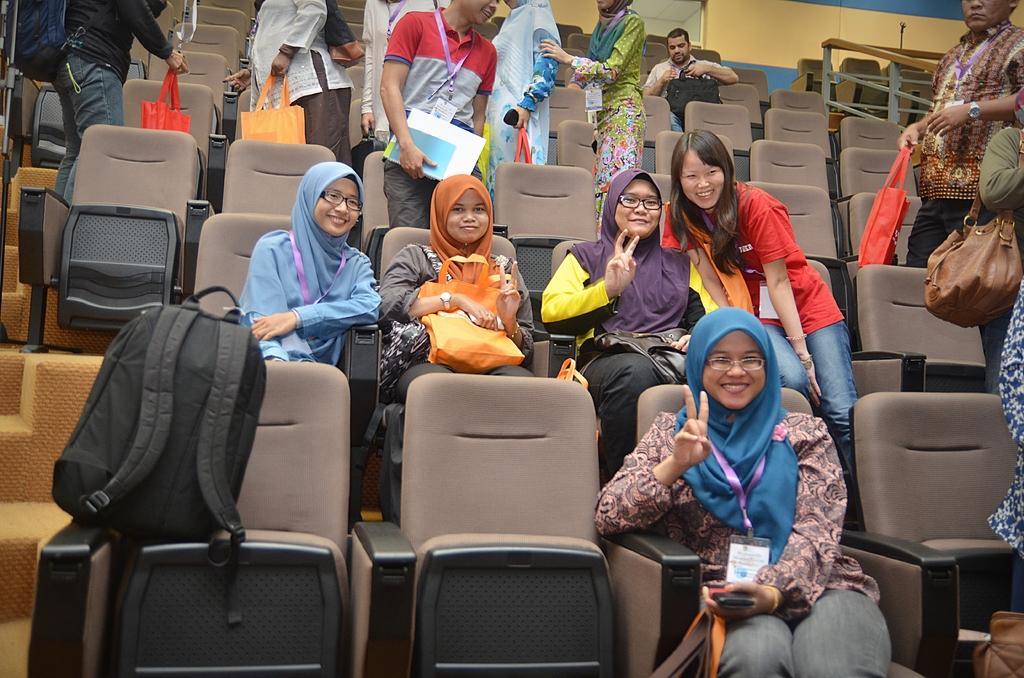How would you summarize this image in a sentence or two? In this image I see number of people in which few of them are sitting and most of them are standing, I can also see few bags and I see that these women are smiling and I see number of chairs. 